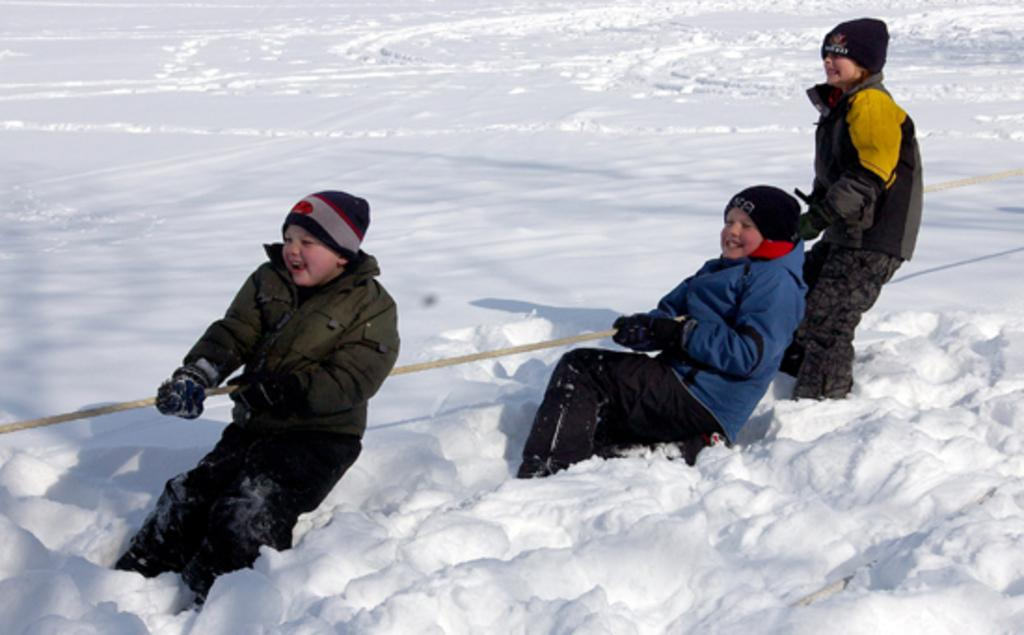How many boys are in the image? There are boys in the image. What are the boys holding in the image? The boys are holding a rope. What is the surface at the bottom of the image covered with? There is snow on the surface at the bottom of the image. How many flies can be seen on the boys in the image? There are no flies visible on the boys in the image. What type of love is being expressed by the boys in the image? The image does not depict any expression of love; it simply shows boys holding a rope. 